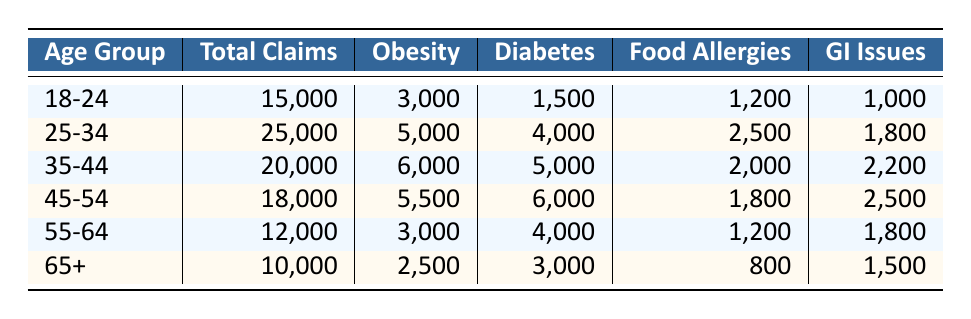What age group has the highest number of total claims? The total claims for each age group are as follows: 18-24: 15,000, 25-34: 25,000, 35-44: 20,000, 45-54: 18,000, 55-64: 12,000, and 65+: 10,000. The highest value is 25,000 for the 25-34 age group.
Answer: 25-34 What is the total number of food-related claims for age group 45-54? For the 45-54 age group, the food-related conditions are: obesity (5,500), diabetes (6,000), food allergies (1,800), and gastrointestinal issues (2,500). Adding these gives: 5,500 + 6,000 + 1,800 + 2,500 = 16,800.
Answer: 16,800 Is the number of obesity claims in the age group 35-44 greater than in age group 55-64? The obesity claims are 6,000 for 35-44 and 3,000 for 55-64. Since 6,000 is greater than 3,000, the statement is true.
Answer: Yes What is the average number of diabetes claims across all age groups? The diabetes claims are as follows: 1,500 (18-24), 4,000 (25-34), 5,000 (35-44), 6,000 (45-54), 4,000 (55-64), and 3,000 (65+). Summing these gives: 1,500 + 4,000 + 5,000 + 6,000 + 4,000 + 3,000 = 23,500. There are 6 age groups, so the average is 23,500 / 6 = 3,916.67.
Answer: 3,916.67 Which age group has the lowest claims for food allergies? The food allergy claims are: 1,200 (18-24), 2,500 (25-34), 2,000 (35-44), 1,800 (45-54), 1,200 (55-64), and 800 (65+). The lowest is 800 for the 65+ group.
Answer: 65+ 